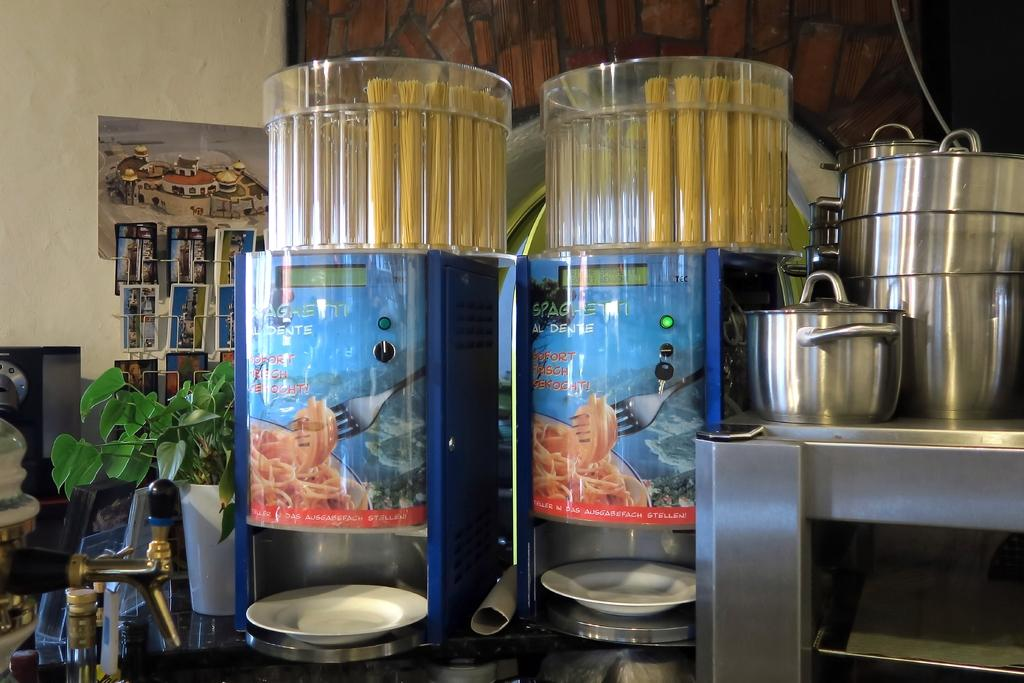<image>
Describe the image concisely. Two large containers holding spaghetti al dente sit on a counter next to some cooking pots. 